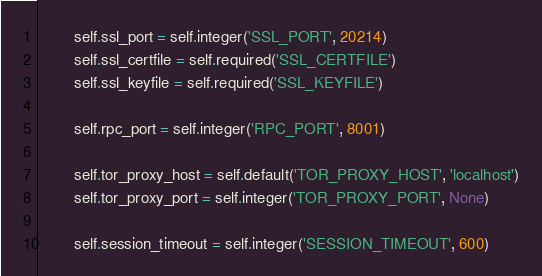<code> <loc_0><loc_0><loc_500><loc_500><_Python_>
        self.ssl_port = self.integer('SSL_PORT', 20214)
        self.ssl_certfile = self.required('SSL_CERTFILE')
        self.ssl_keyfile = self.required('SSL_KEYFILE')

        self.rpc_port = self.integer('RPC_PORT', 8001)

        self.tor_proxy_host = self.default('TOR_PROXY_HOST', 'localhost')
        self.tor_proxy_port = self.integer('TOR_PROXY_PORT', None)

        self.session_timeout = self.integer('SESSION_TIMEOUT', 600)
</code> 